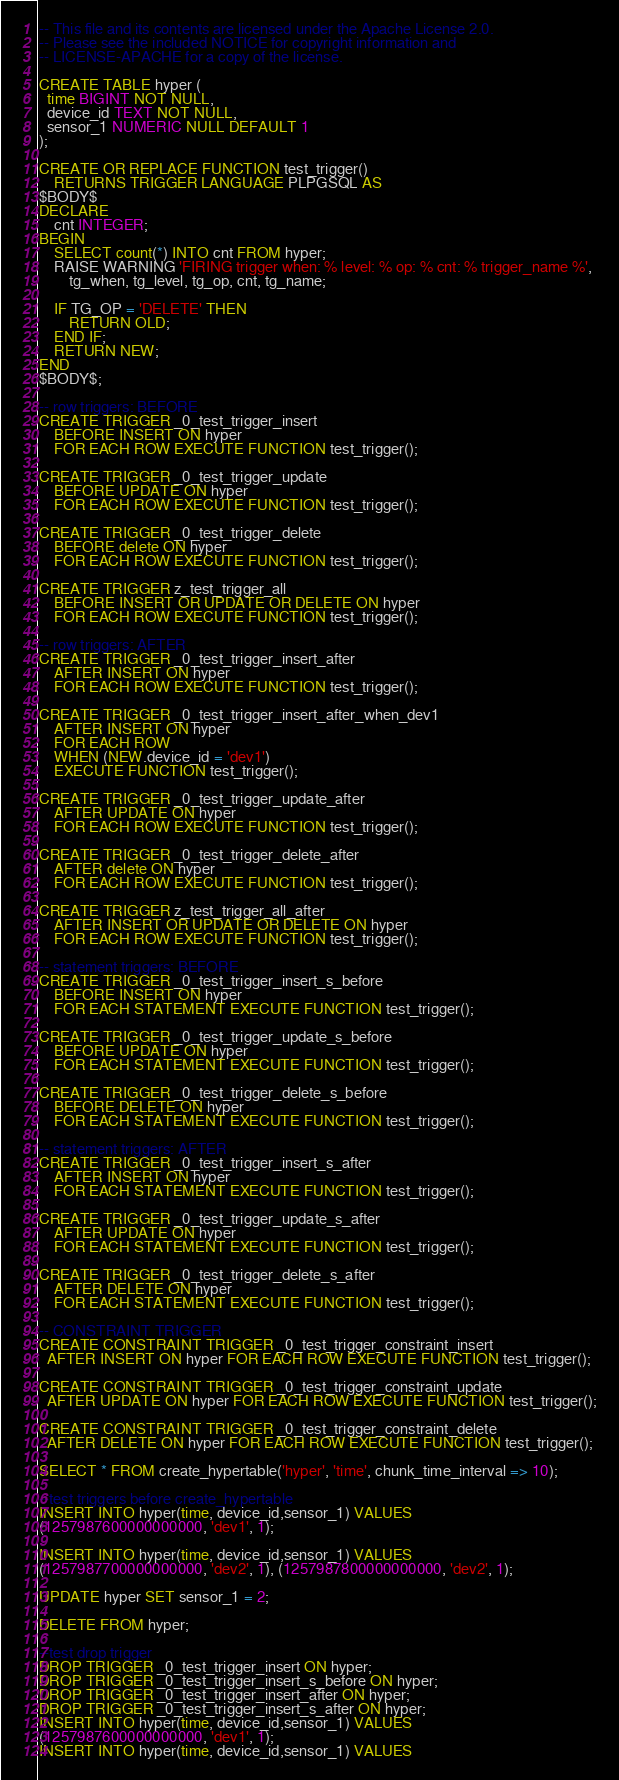Convert code to text. <code><loc_0><loc_0><loc_500><loc_500><_SQL_>-- This file and its contents are licensed under the Apache License 2.0.
-- Please see the included NOTICE for copyright information and
-- LICENSE-APACHE for a copy of the license.

CREATE TABLE hyper (
  time BIGINT NOT NULL,
  device_id TEXT NOT NULL,
  sensor_1 NUMERIC NULL DEFAULT 1
);

CREATE OR REPLACE FUNCTION test_trigger()
    RETURNS TRIGGER LANGUAGE PLPGSQL AS
$BODY$
DECLARE
    cnt INTEGER;
BEGIN
    SELECT count(*) INTO cnt FROM hyper;
    RAISE WARNING 'FIRING trigger when: % level: % op: % cnt: % trigger_name %',
        tg_when, tg_level, tg_op, cnt, tg_name;

    IF TG_OP = 'DELETE' THEN
        RETURN OLD;
    END IF;
    RETURN NEW;
END
$BODY$;

-- row triggers: BEFORE
CREATE TRIGGER _0_test_trigger_insert
    BEFORE INSERT ON hyper
    FOR EACH ROW EXECUTE FUNCTION test_trigger();

CREATE TRIGGER _0_test_trigger_update
    BEFORE UPDATE ON hyper
    FOR EACH ROW EXECUTE FUNCTION test_trigger();

CREATE TRIGGER _0_test_trigger_delete
    BEFORE delete ON hyper
    FOR EACH ROW EXECUTE FUNCTION test_trigger();

CREATE TRIGGER z_test_trigger_all
    BEFORE INSERT OR UPDATE OR DELETE ON hyper
    FOR EACH ROW EXECUTE FUNCTION test_trigger();

-- row triggers: AFTER
CREATE TRIGGER _0_test_trigger_insert_after
    AFTER INSERT ON hyper
    FOR EACH ROW EXECUTE FUNCTION test_trigger();

CREATE TRIGGER _0_test_trigger_insert_after_when_dev1
    AFTER INSERT ON hyper
    FOR EACH ROW
    WHEN (NEW.device_id = 'dev1')
    EXECUTE FUNCTION test_trigger();

CREATE TRIGGER _0_test_trigger_update_after
    AFTER UPDATE ON hyper
    FOR EACH ROW EXECUTE FUNCTION test_trigger();

CREATE TRIGGER _0_test_trigger_delete_after
    AFTER delete ON hyper
    FOR EACH ROW EXECUTE FUNCTION test_trigger();

CREATE TRIGGER z_test_trigger_all_after
    AFTER INSERT OR UPDATE OR DELETE ON hyper
    FOR EACH ROW EXECUTE FUNCTION test_trigger();

-- statement triggers: BEFORE
CREATE TRIGGER _0_test_trigger_insert_s_before
    BEFORE INSERT ON hyper
    FOR EACH STATEMENT EXECUTE FUNCTION test_trigger();

CREATE TRIGGER _0_test_trigger_update_s_before
    BEFORE UPDATE ON hyper
    FOR EACH STATEMENT EXECUTE FUNCTION test_trigger();

CREATE TRIGGER _0_test_trigger_delete_s_before
    BEFORE DELETE ON hyper
    FOR EACH STATEMENT EXECUTE FUNCTION test_trigger();

-- statement triggers: AFTER
CREATE TRIGGER _0_test_trigger_insert_s_after
    AFTER INSERT ON hyper
    FOR EACH STATEMENT EXECUTE FUNCTION test_trigger();

CREATE TRIGGER _0_test_trigger_update_s_after
    AFTER UPDATE ON hyper
    FOR EACH STATEMENT EXECUTE FUNCTION test_trigger();

CREATE TRIGGER _0_test_trigger_delete_s_after
    AFTER DELETE ON hyper
    FOR EACH STATEMENT EXECUTE FUNCTION test_trigger();

-- CONSTRAINT TRIGGER
CREATE CONSTRAINT TRIGGER _0_test_trigger_constraint_insert
  AFTER INSERT ON hyper FOR EACH ROW EXECUTE FUNCTION test_trigger();

CREATE CONSTRAINT TRIGGER _0_test_trigger_constraint_update
  AFTER UPDATE ON hyper FOR EACH ROW EXECUTE FUNCTION test_trigger();

CREATE CONSTRAINT TRIGGER _0_test_trigger_constraint_delete
  AFTER DELETE ON hyper FOR EACH ROW EXECUTE FUNCTION test_trigger();

SELECT * FROM create_hypertable('hyper', 'time', chunk_time_interval => 10);

--test triggers before create_hypertable
INSERT INTO hyper(time, device_id,sensor_1) VALUES
(1257987600000000000, 'dev1', 1);

INSERT INTO hyper(time, device_id,sensor_1) VALUES
(1257987700000000000, 'dev2', 1), (1257987800000000000, 'dev2', 1);

UPDATE hyper SET sensor_1 = 2;

DELETE FROM hyper;

--test drop trigger
DROP TRIGGER _0_test_trigger_insert ON hyper;
DROP TRIGGER _0_test_trigger_insert_s_before ON hyper;
DROP TRIGGER _0_test_trigger_insert_after ON hyper;
DROP TRIGGER _0_test_trigger_insert_s_after ON hyper;
INSERT INTO hyper(time, device_id,sensor_1) VALUES
(1257987600000000000, 'dev1', 1);
INSERT INTO hyper(time, device_id,sensor_1) VALUES</code> 